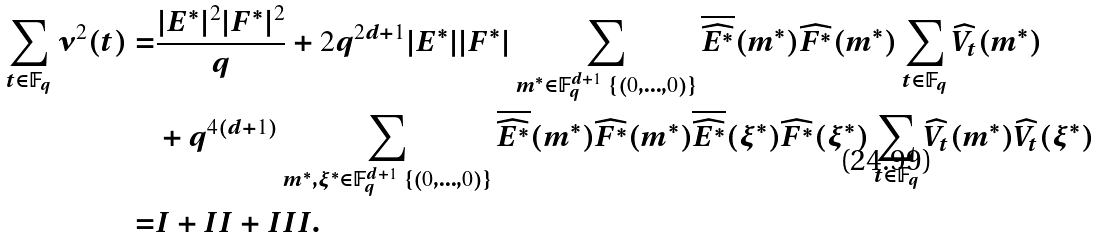Convert formula to latex. <formula><loc_0><loc_0><loc_500><loc_500>\sum _ { t \in { \mathbb { F } _ { q } } } \nu ^ { 2 } ( t ) = & \frac { | E ^ { * } | ^ { 2 } | F ^ { * } | ^ { 2 } } { q } + 2 q ^ { 2 d + 1 } | E ^ { * } | | F ^ { * } | \sum _ { m ^ { * } \in { \mathbb { F } _ { q } ^ { d + 1 } } \ \{ ( 0 , \dots , 0 ) \} } \overline { \widehat { E ^ { * } } } ( m ^ { * } ) \widehat { F ^ { * } } ( m ^ { * } ) \sum _ { t \in { \mathbb { F } _ { q } } } \widehat { V _ { t } } ( m ^ { * } ) \\ & + q ^ { 4 ( d + 1 ) } \sum _ { m ^ { * } , \xi ^ { * } \in { \mathbb { F } _ { q } ^ { d + 1 } } \ \{ ( 0 , \dots , 0 ) \} } \overline { \widehat { E ^ { * } } } ( m ^ { * } ) \widehat { F ^ { * } } ( m ^ { * } ) \overline { \widehat { E ^ { * } } } ( \xi ^ { * } ) \widehat { F ^ { * } } ( \xi ^ { * } ) \sum _ { t \in { \mathbb { F } _ { q } } } \widehat { V _ { t } } ( m ^ { * } ) \widehat { V _ { t } } ( \xi ^ { * } ) \\ = & I + I I + I I I .</formula> 